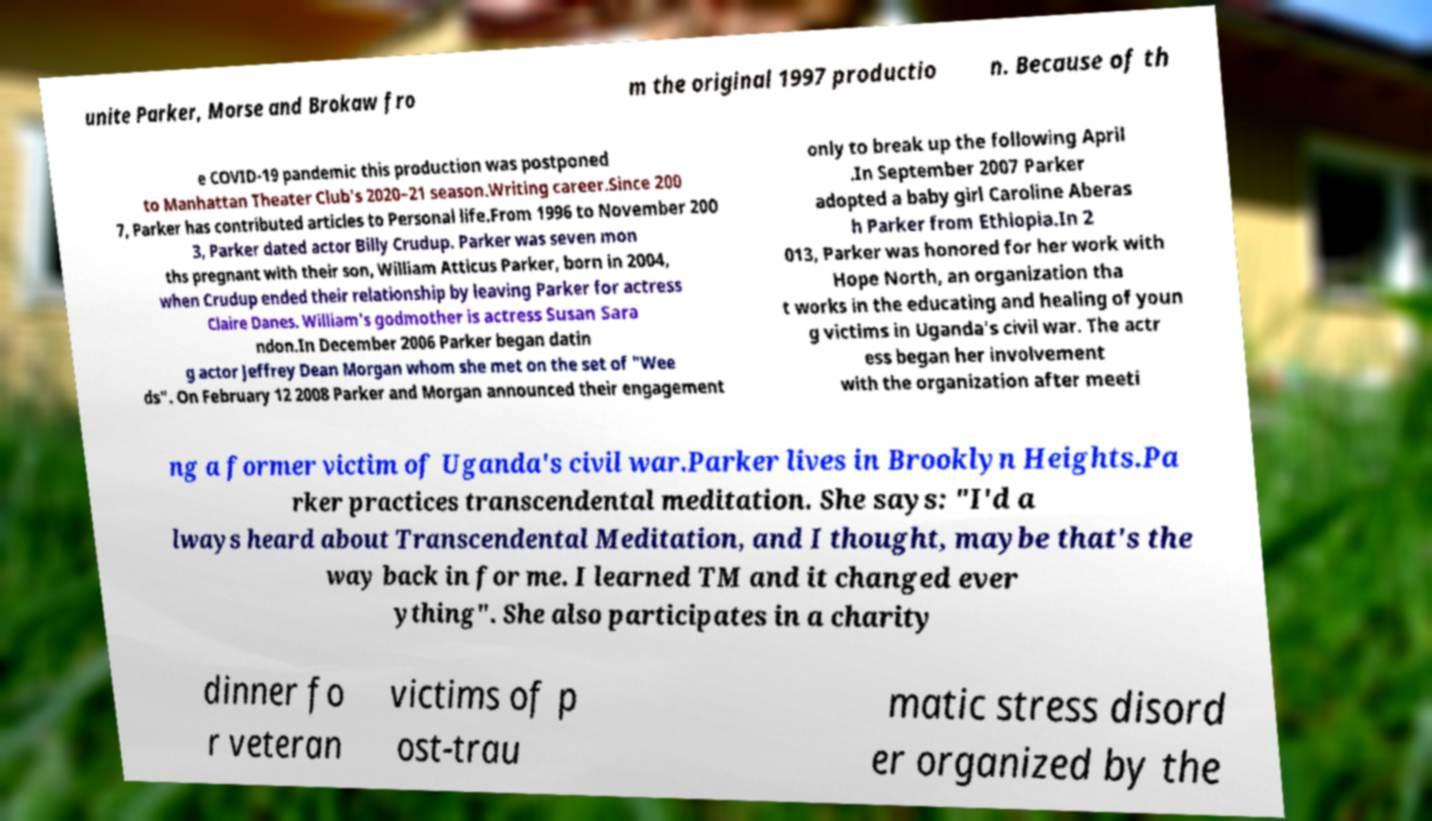For documentation purposes, I need the text within this image transcribed. Could you provide that? unite Parker, Morse and Brokaw fro m the original 1997 productio n. Because of th e COVID-19 pandemic this production was postponed to Manhattan Theater Club's 2020–21 season.Writing career.Since 200 7, Parker has contributed articles to Personal life.From 1996 to November 200 3, Parker dated actor Billy Crudup. Parker was seven mon ths pregnant with their son, William Atticus Parker, born in 2004, when Crudup ended their relationship by leaving Parker for actress Claire Danes. William's godmother is actress Susan Sara ndon.In December 2006 Parker began datin g actor Jeffrey Dean Morgan whom she met on the set of "Wee ds". On February 12 2008 Parker and Morgan announced their engagement only to break up the following April .In September 2007 Parker adopted a baby girl Caroline Aberas h Parker from Ethiopia.In 2 013, Parker was honored for her work with Hope North, an organization tha t works in the educating and healing of youn g victims in Uganda's civil war. The actr ess began her involvement with the organization after meeti ng a former victim of Uganda's civil war.Parker lives in Brooklyn Heights.Pa rker practices transcendental meditation. She says: "I'd a lways heard about Transcendental Meditation, and I thought, maybe that's the way back in for me. I learned TM and it changed ever ything". She also participates in a charity dinner fo r veteran victims of p ost-trau matic stress disord er organized by the 